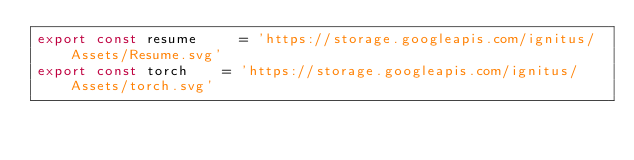Convert code to text. <code><loc_0><loc_0><loc_500><loc_500><_JavaScript_>export const resume 		= 'https://storage.googleapis.com/ignitus/Assets/Resume.svg'
export const torch 		= 'https://storage.googleapis.com/ignitus/Assets/torch.svg'
</code> 